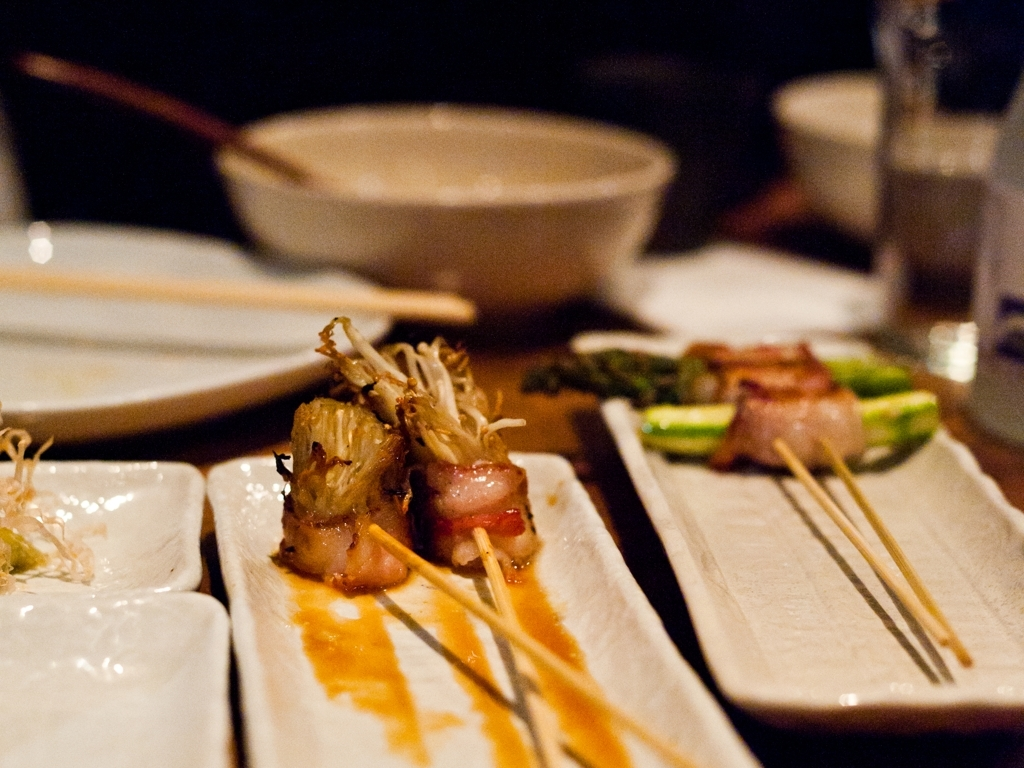What is the quality of the color?
 Vibrant 